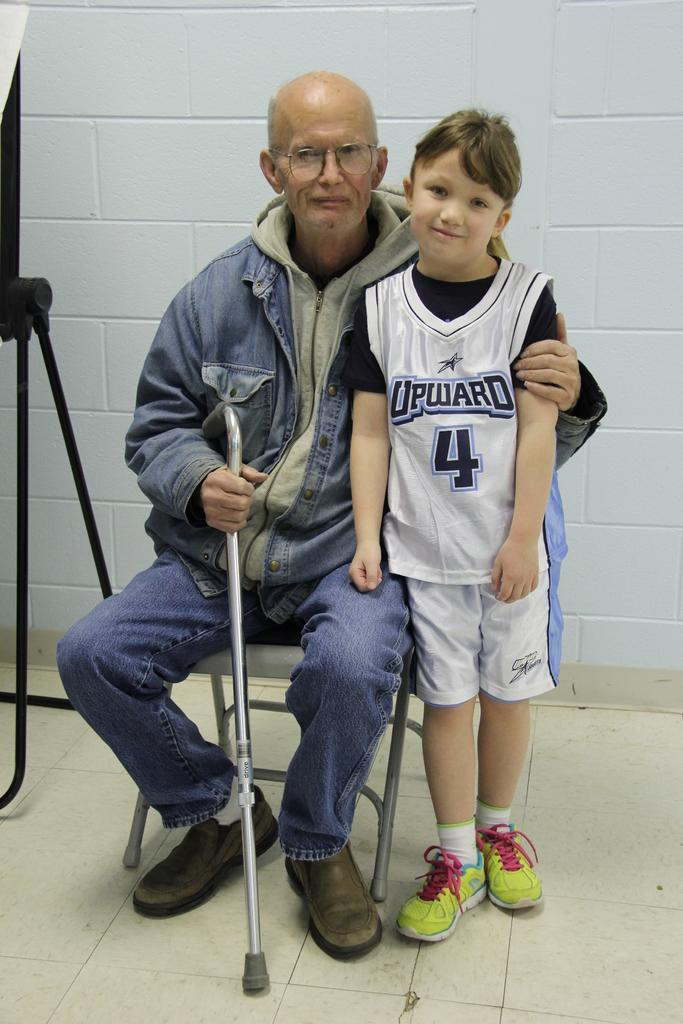<image>
Offer a succinct explanation of the picture presented. The young boy pictured is wearing the number 4 on their top. 